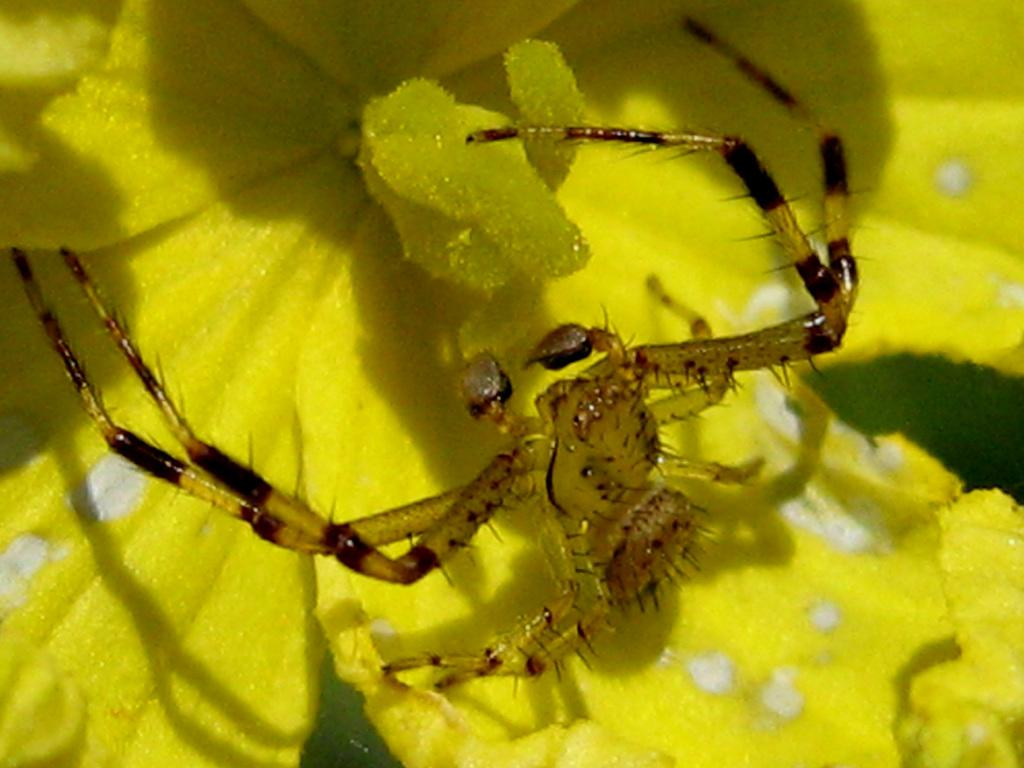What is present on the flower in the image? There is an insect on the flower in the image. What is the insect doing on the flower? The insect is likely feeding on the flower or collecting pollen. What can be seen in front of the insect? There are pollen grains in front of the insect. What part of the flower is visible in the background of the image? There are petals of the flower in the background of the image. What thought is the insect having while sitting on the flower? Insects do not have thoughts like humans do, so it is not possible to determine what the insect might be thinking. 